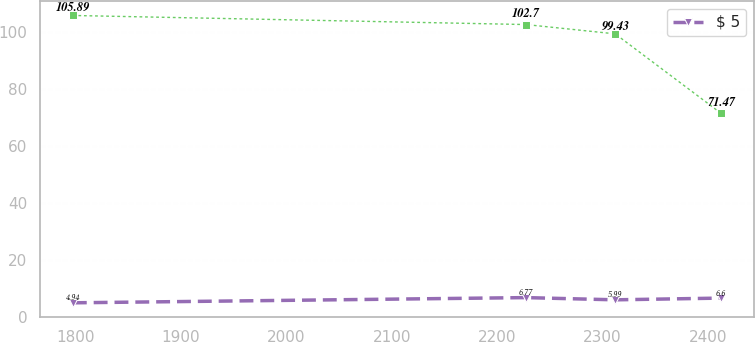<chart> <loc_0><loc_0><loc_500><loc_500><line_chart><ecel><fcel>Unnamed: 1<fcel>$ 5<nl><fcel>1797.79<fcel>105.89<fcel>4.94<nl><fcel>2227.21<fcel>102.7<fcel>6.77<nl><fcel>2311.92<fcel>99.43<fcel>5.99<nl><fcel>2412.41<fcel>71.47<fcel>6.6<nl></chart> 